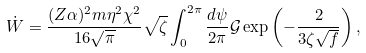Convert formula to latex. <formula><loc_0><loc_0><loc_500><loc_500>\dot { W } = \frac { ( Z \alpha ) ^ { 2 } m \eta ^ { 2 } \chi ^ { 2 } } { 1 6 \sqrt { \pi } } \sqrt { \zeta } \int _ { 0 } ^ { 2 \pi } \frac { d \psi } { 2 \pi } \mathcal { G } \exp \left ( - \frac { 2 } { 3 \zeta \sqrt { f } } \right ) ,</formula> 